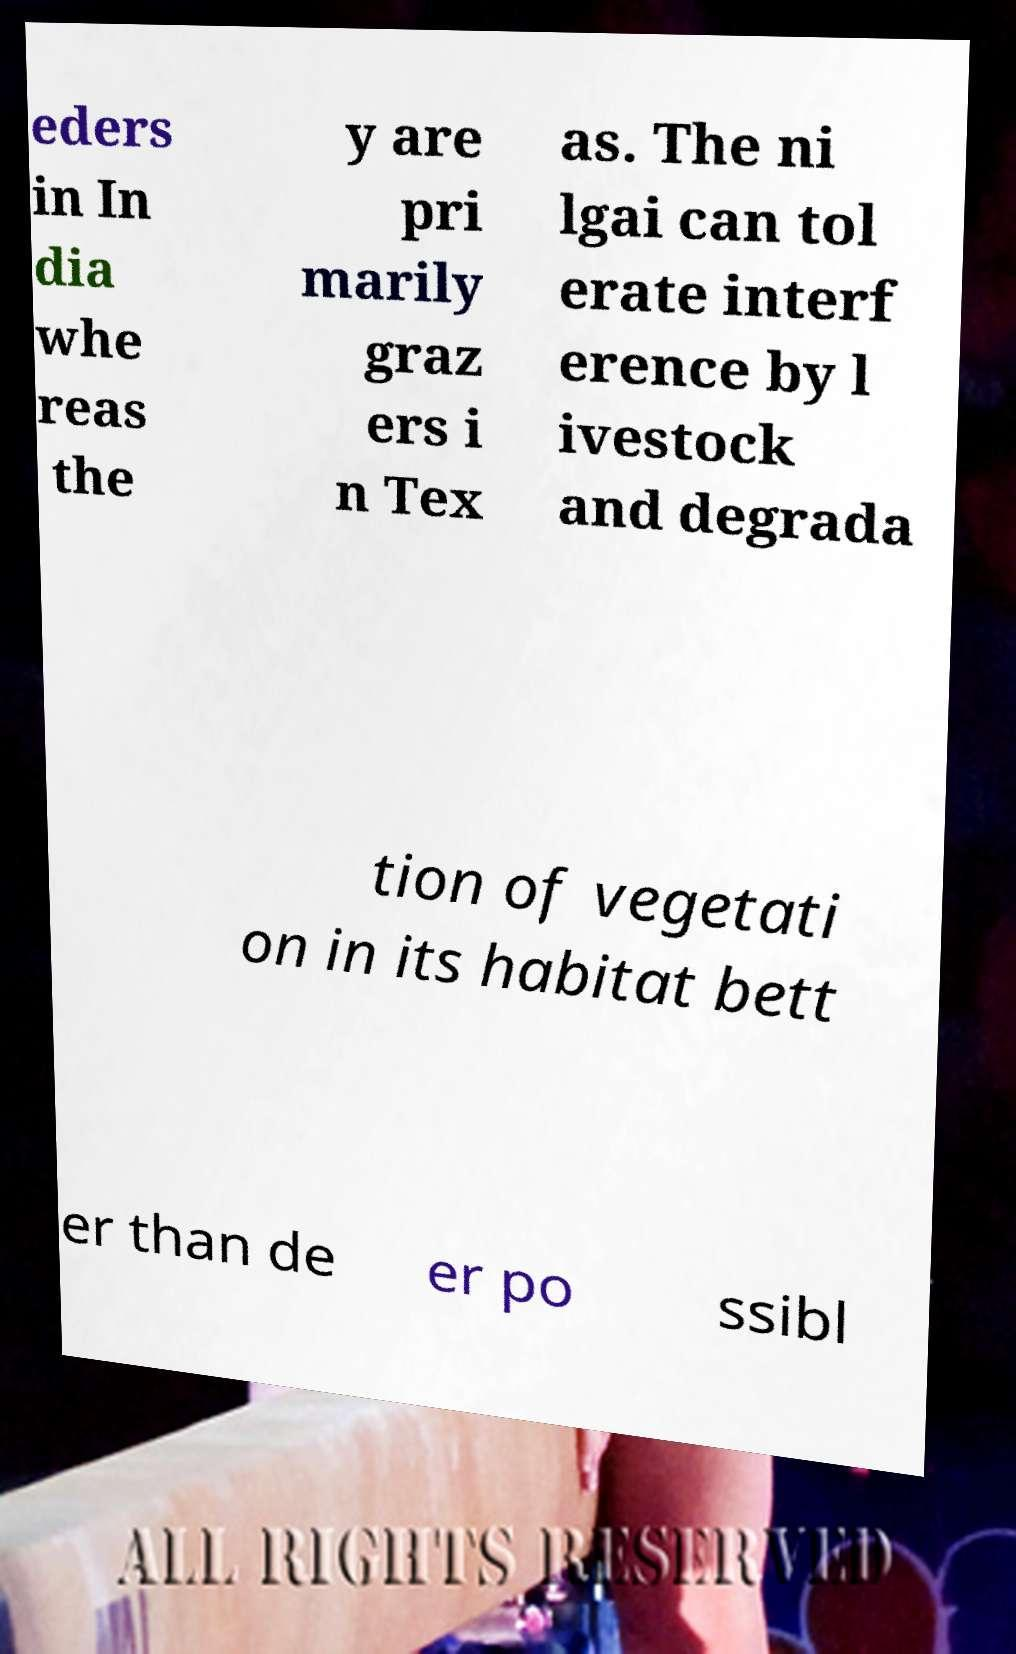Could you extract and type out the text from this image? eders in In dia whe reas the y are pri marily graz ers i n Tex as. The ni lgai can tol erate interf erence by l ivestock and degrada tion of vegetati on in its habitat bett er than de er po ssibl 